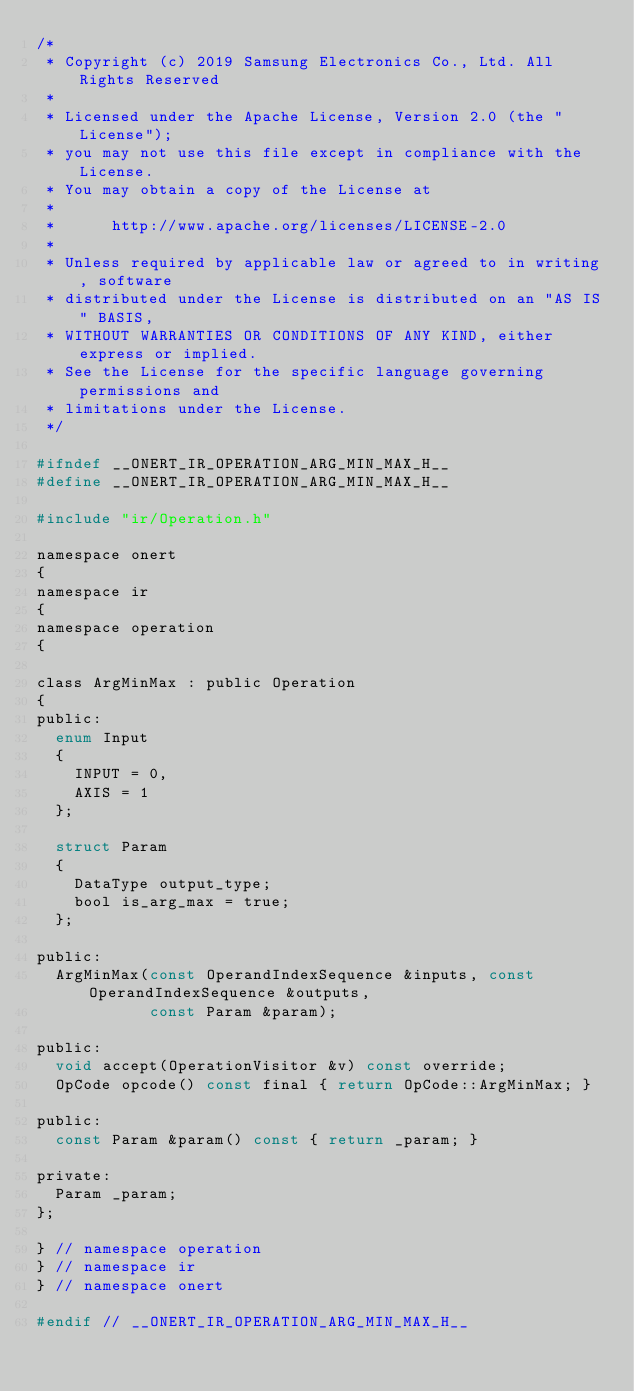Convert code to text. <code><loc_0><loc_0><loc_500><loc_500><_C_>/*
 * Copyright (c) 2019 Samsung Electronics Co., Ltd. All Rights Reserved
 *
 * Licensed under the Apache License, Version 2.0 (the "License");
 * you may not use this file except in compliance with the License.
 * You may obtain a copy of the License at
 *
 *      http://www.apache.org/licenses/LICENSE-2.0
 *
 * Unless required by applicable law or agreed to in writing, software
 * distributed under the License is distributed on an "AS IS" BASIS,
 * WITHOUT WARRANTIES OR CONDITIONS OF ANY KIND, either express or implied.
 * See the License for the specific language governing permissions and
 * limitations under the License.
 */

#ifndef __ONERT_IR_OPERATION_ARG_MIN_MAX_H__
#define __ONERT_IR_OPERATION_ARG_MIN_MAX_H__

#include "ir/Operation.h"

namespace onert
{
namespace ir
{
namespace operation
{

class ArgMinMax : public Operation
{
public:
  enum Input
  {
    INPUT = 0,
    AXIS = 1
  };

  struct Param
  {
    DataType output_type;
    bool is_arg_max = true;
  };

public:
  ArgMinMax(const OperandIndexSequence &inputs, const OperandIndexSequence &outputs,
            const Param &param);

public:
  void accept(OperationVisitor &v) const override;
  OpCode opcode() const final { return OpCode::ArgMinMax; }

public:
  const Param &param() const { return _param; }

private:
  Param _param;
};

} // namespace operation
} // namespace ir
} // namespace onert

#endif // __ONERT_IR_OPERATION_ARG_MIN_MAX_H__
</code> 